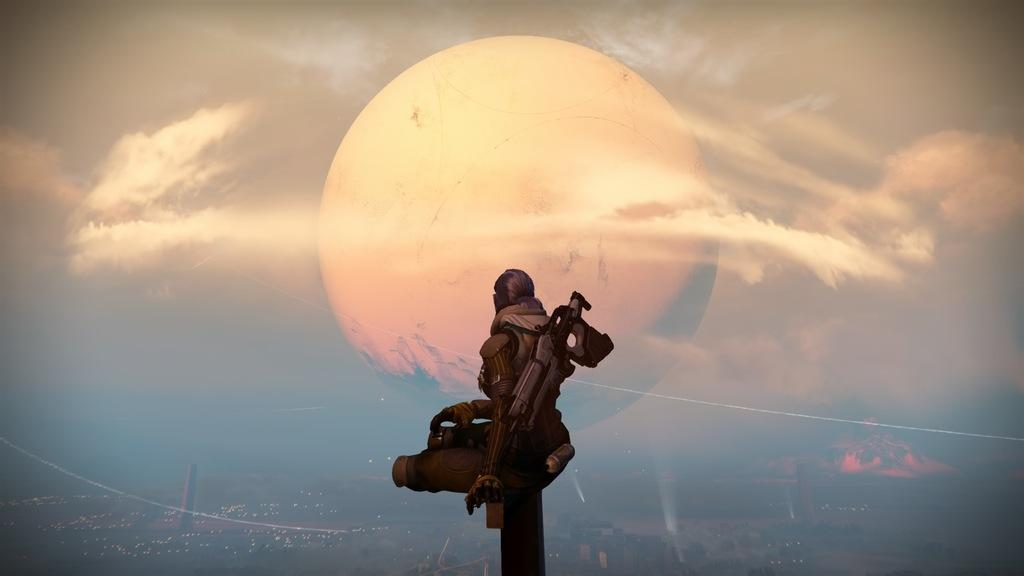What type of image is this? The image is animated. Can you describe the person in the image? There is a person in the image, but no specific details about their appearance or actions are provided. What can be seen in the sky in the image? The sky is visible in the image, and the moon is present. What is located at the bottom of the image? The city is visible at the bottom of the image. How many bikes are being ridden by the person in the image? There is no information about bikes or the person riding them in the image. 